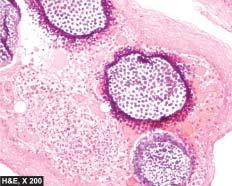what are present in sporangia as well as are intermingled in the inflammatory cell infiltrate?
Answer the question using a single word or phrase. Spores 